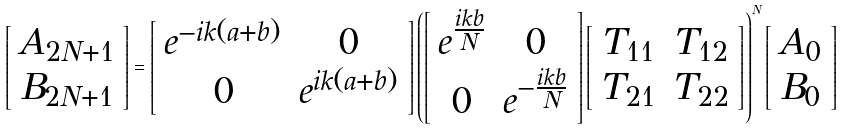Convert formula to latex. <formula><loc_0><loc_0><loc_500><loc_500>\left [ \begin{array} { c } A _ { 2 N + 1 } \\ B _ { 2 N + 1 } \end{array} \right ] = \left [ \begin{array} { c c } e ^ { - i k ( a + b ) } & 0 \\ 0 & e ^ { i k ( a + b ) } \end{array} \right ] \left ( \left [ \begin{array} { c c } e ^ { \frac { i k b } { N } } & 0 \\ 0 & e ^ { - \frac { i k b } { N } } \end{array} \right ] \left [ \begin{array} { c c } T _ { 1 1 } & T _ { 1 2 } \\ T _ { 2 1 } & T _ { 2 2 } \end{array} \right ] \right ) ^ { N } \left [ \begin{array} { c } A _ { 0 } \\ B _ { 0 } \end{array} \right ]</formula> 